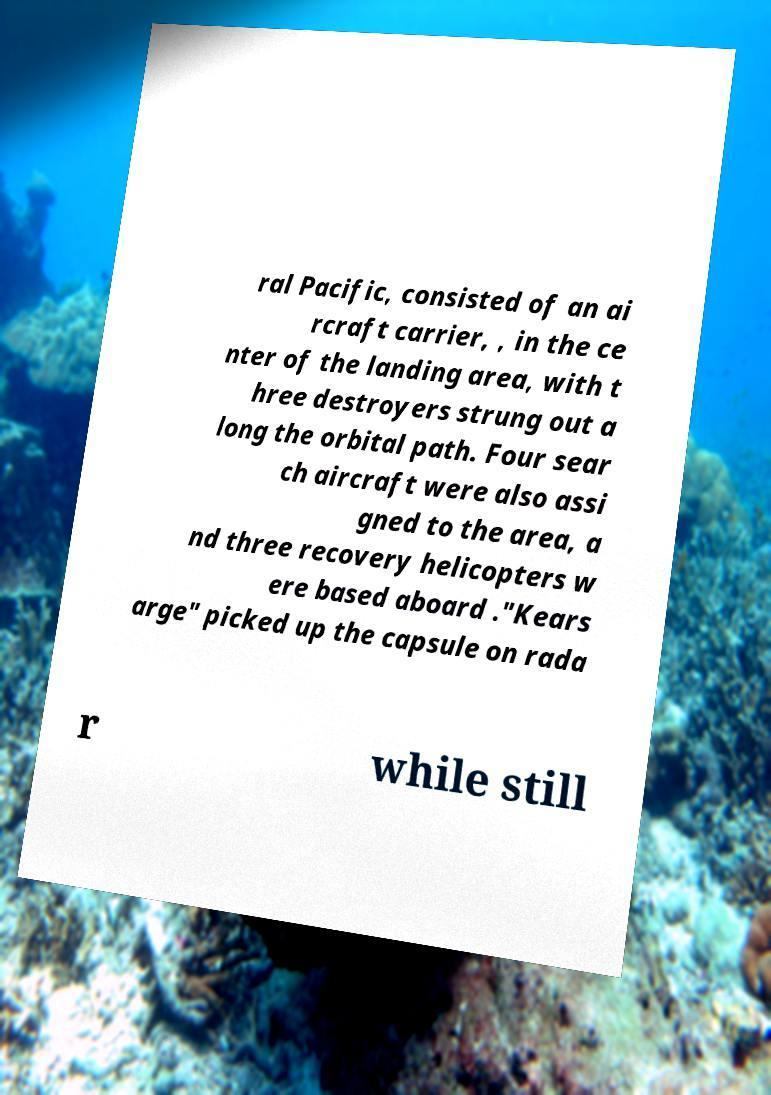Please identify and transcribe the text found in this image. ral Pacific, consisted of an ai rcraft carrier, , in the ce nter of the landing area, with t hree destroyers strung out a long the orbital path. Four sear ch aircraft were also assi gned to the area, a nd three recovery helicopters w ere based aboard ."Kears arge" picked up the capsule on rada r while still 